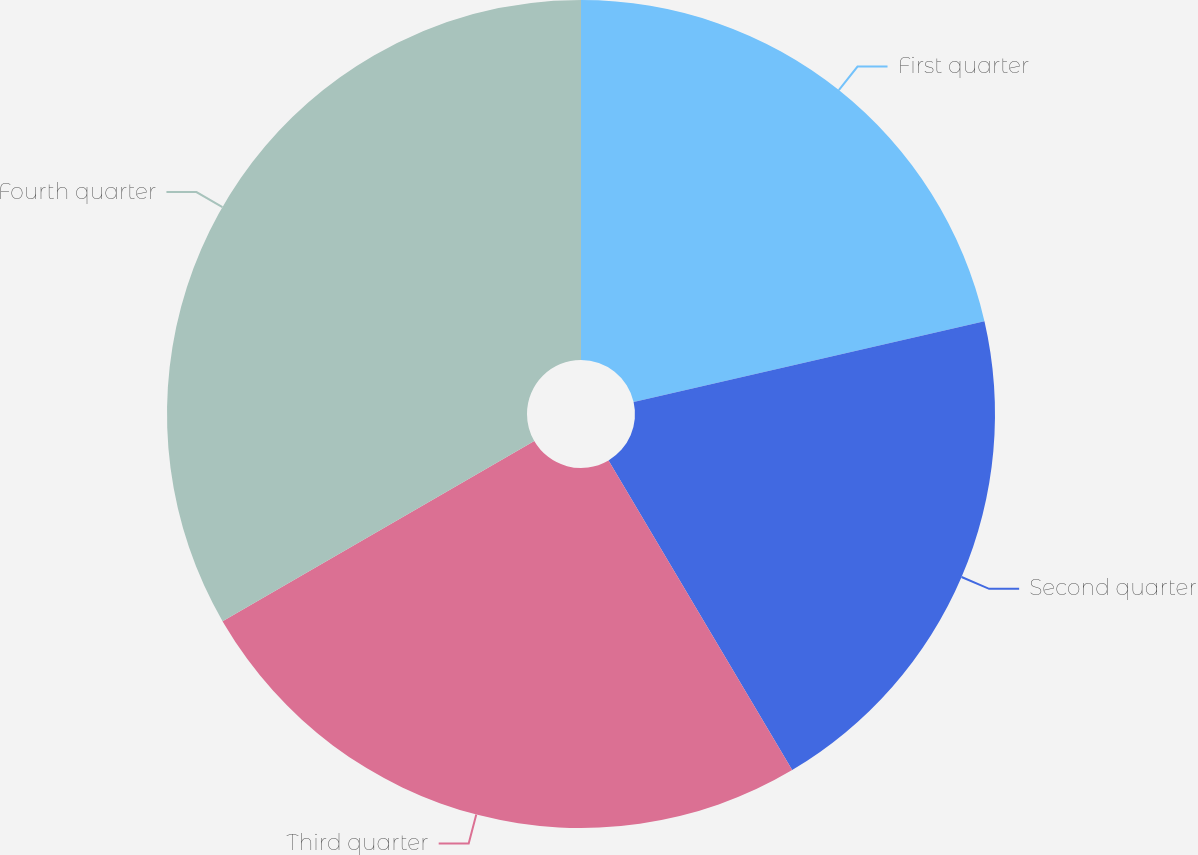<chart> <loc_0><loc_0><loc_500><loc_500><pie_chart><fcel>First quarter<fcel>Second quarter<fcel>Third quarter<fcel>Fourth quarter<nl><fcel>21.4%<fcel>20.08%<fcel>25.18%<fcel>33.34%<nl></chart> 